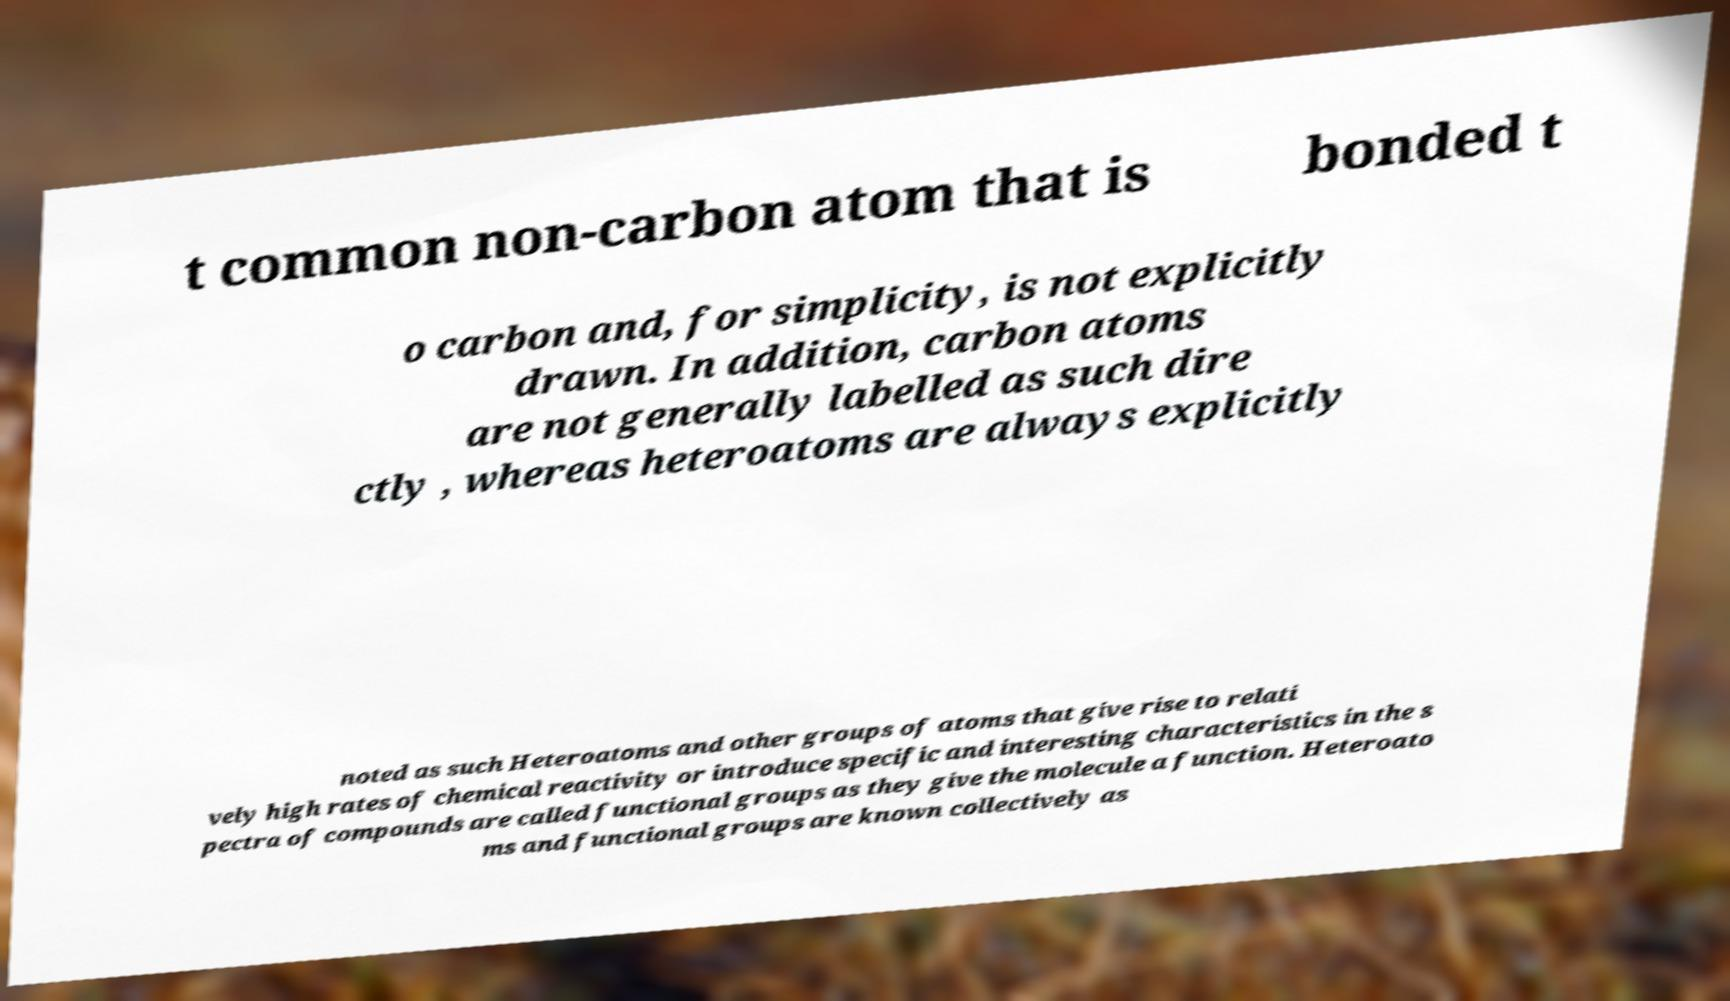For documentation purposes, I need the text within this image transcribed. Could you provide that? t common non-carbon atom that is bonded t o carbon and, for simplicity, is not explicitly drawn. In addition, carbon atoms are not generally labelled as such dire ctly , whereas heteroatoms are always explicitly noted as such Heteroatoms and other groups of atoms that give rise to relati vely high rates of chemical reactivity or introduce specific and interesting characteristics in the s pectra of compounds are called functional groups as they give the molecule a function. Heteroato ms and functional groups are known collectively as 